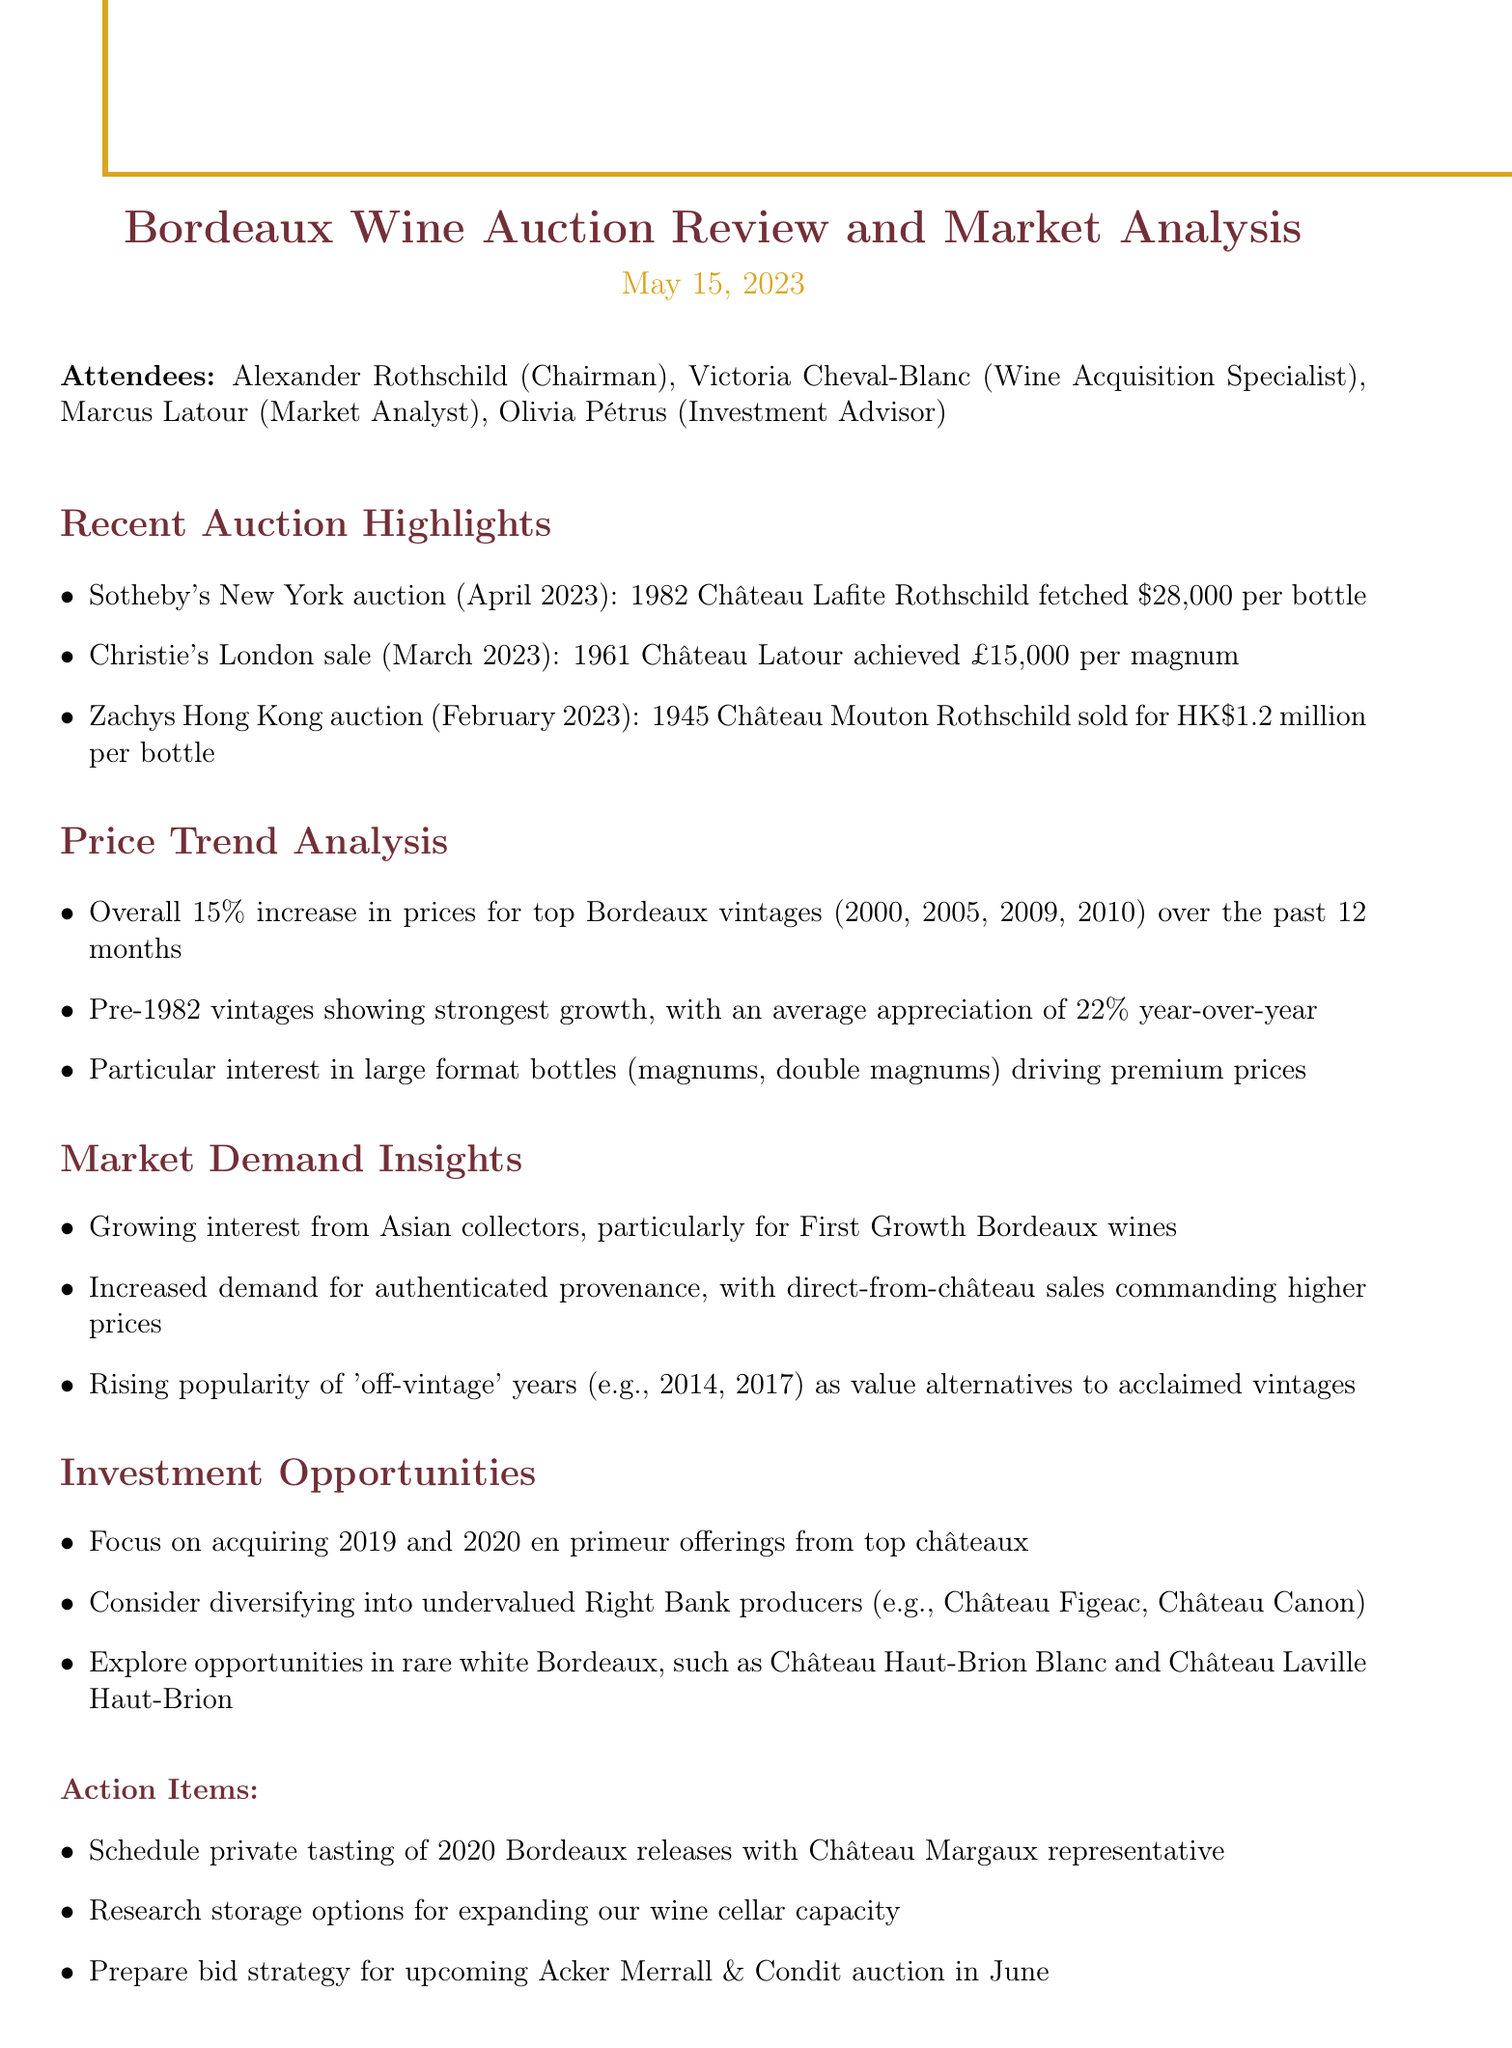What was the highest price achieved for a bottle of wine at the Sotheby's New York auction? The document states that the 1982 Château Lafite Rothschild fetched $28,000 per bottle at Sotheby's New York auction.
Answer: $28,000 What percentage increase was noted for top Bordeaux vintages over the past 12 months? The document mentions an overall 15% increase in prices for top Bordeaux vintages over the past year.
Answer: 15% Which vintages showed the strongest growth in price appreciation? According to the document, pre-1982 vintages showed the strongest growth with an average appreciation of 22% year-over-year.
Answer: Pre-1982 vintages What is driving the premium prices for Bordeaux wines? The document indicates that particular interest in large format bottles (magnums, double magnums) is driving premium prices.
Answer: Large format bottles Which regions are showing a growing interest in First Growth Bordeaux wines? The document highlights growing interest from Asian collectors for First Growth Bordeaux wines.
Answer: Asian collectors What specific investment opportunities were suggested in the meeting? The document lists acquiring 2019 and 2020 en primeur offerings from top châteaux as a key investment opportunity.
Answer: 2019 and 2020 en primeur What is scheduled as an action item regarding wine tasting? The document mentions scheduling a private tasting of 2020 Bordeaux releases with the Château Margaux representative as an action item.
Answer: Private tasting with Château Margaux When is the next auction where a bid strategy is to be prepared? The document specifies that a bid strategy needs to be prepared for the Acker Merrall & Condit auction happening in June.
Answer: June What types of wines are suggested for diversification investments? The document recommends considering diversifying into undervalued Right Bank producers.
Answer: Undervalued Right Bank producers 